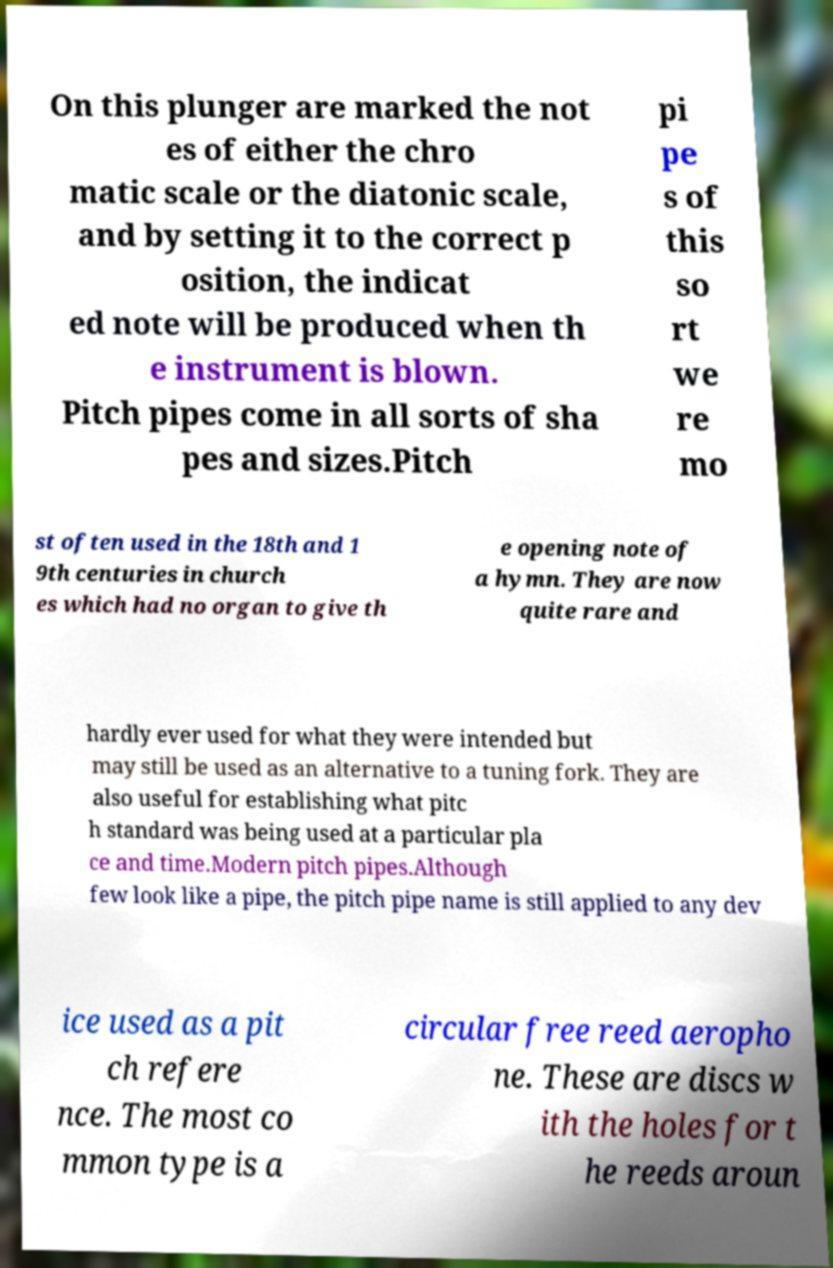Please identify and transcribe the text found in this image. On this plunger are marked the not es of either the chro matic scale or the diatonic scale, and by setting it to the correct p osition, the indicat ed note will be produced when th e instrument is blown. Pitch pipes come in all sorts of sha pes and sizes.Pitch pi pe s of this so rt we re mo st often used in the 18th and 1 9th centuries in church es which had no organ to give th e opening note of a hymn. They are now quite rare and hardly ever used for what they were intended but may still be used as an alternative to a tuning fork. They are also useful for establishing what pitc h standard was being used at a particular pla ce and time.Modern pitch pipes.Although few look like a pipe, the pitch pipe name is still applied to any dev ice used as a pit ch refere nce. The most co mmon type is a circular free reed aeropho ne. These are discs w ith the holes for t he reeds aroun 